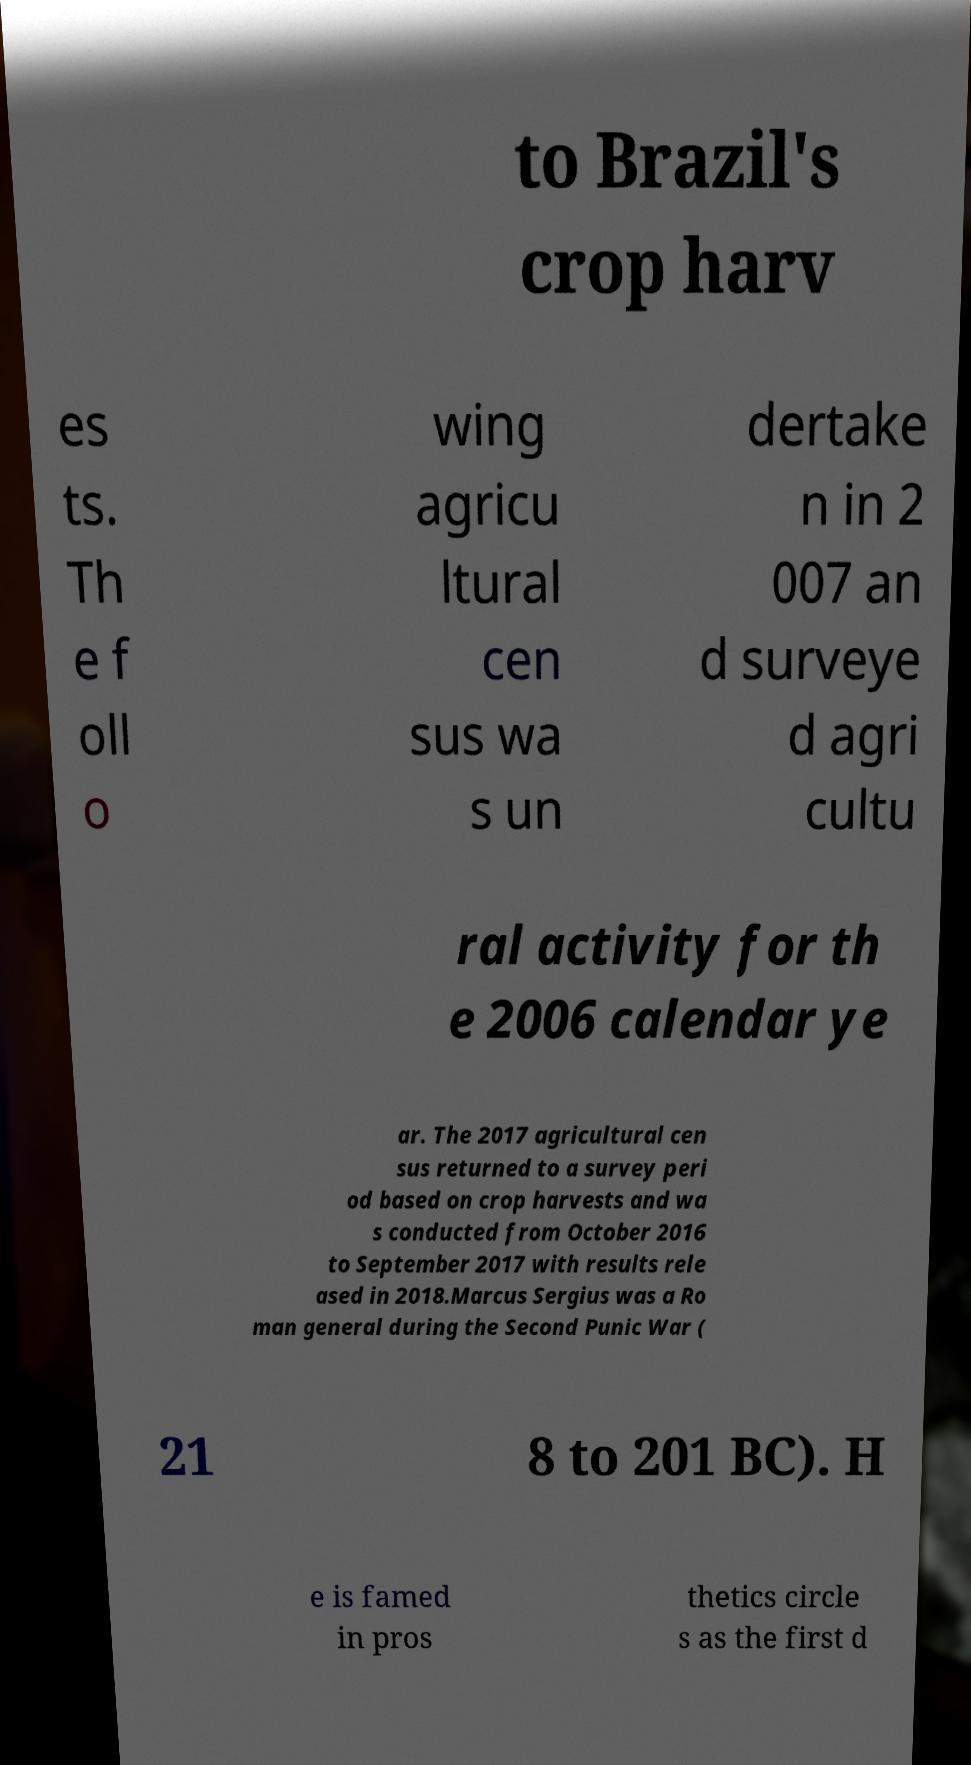Please read and relay the text visible in this image. What does it say? to Brazil's crop harv es ts. Th e f oll o wing agricu ltural cen sus wa s un dertake n in 2 007 an d surveye d agri cultu ral activity for th e 2006 calendar ye ar. The 2017 agricultural cen sus returned to a survey peri od based on crop harvests and wa s conducted from October 2016 to September 2017 with results rele ased in 2018.Marcus Sergius was a Ro man general during the Second Punic War ( 21 8 to 201 BC). H e is famed in pros thetics circle s as the first d 